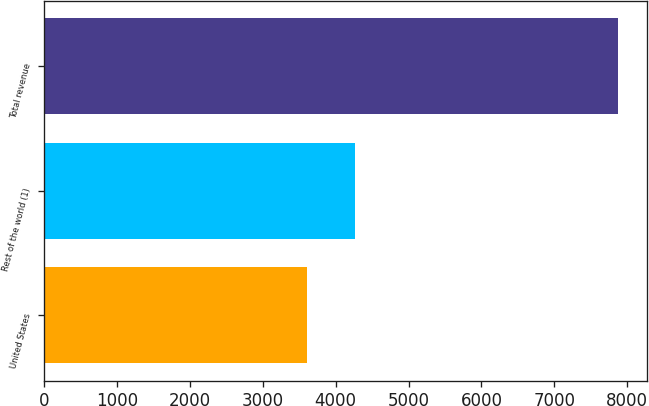<chart> <loc_0><loc_0><loc_500><loc_500><bar_chart><fcel>United States<fcel>Rest of the world (1)<fcel>Total revenue<nl><fcel>3613<fcel>4259<fcel>7872<nl></chart> 